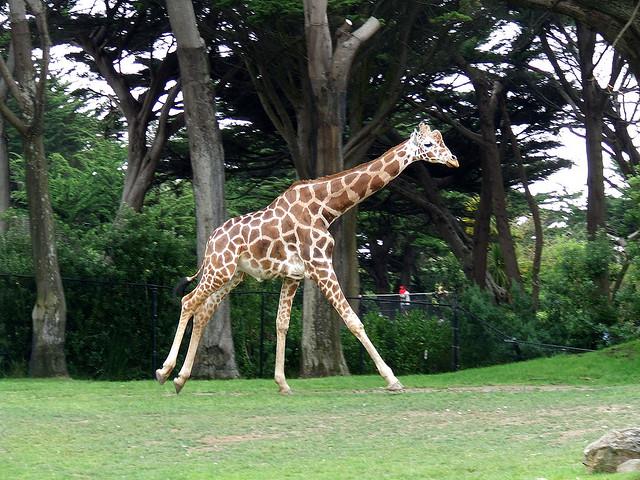Is the giraffe fenced in?
Write a very short answer. Yes. Is he in the grass?
Concise answer only. Yes. What do you think is the purpose of the rocks?
Keep it brief. Decoration. What is the animal doing?
Answer briefly. Walking. How many giraffes are there?
Short answer required. 1. Is the giraffe running?
Quick response, please. Yes. Does the giraffe have his head over the fence?
Write a very short answer. No. 